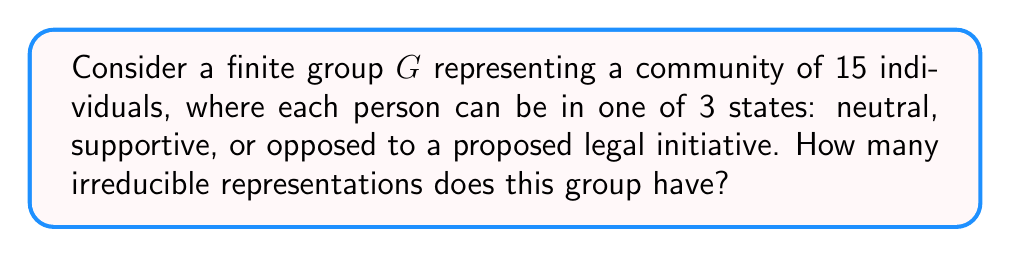Can you answer this question? To determine the number of irreducible representations for a finite group, we can follow these steps:

1. Identify the group: In this case, we have a finite group $G$ with $|G| = 15$.

2. Determine the number of conjugacy classes:
   For a group of order 15, the possible cycle structures are:
   - (1, 1, 1, 1, 1, 1, 1, 1, 1, 1, 1, 1, 1, 1, 1)
   - (3, 3, 3, 3, 3)
   - (5, 5, 5)
   
   There are 3 conjugacy classes corresponding to these cycle structures.

3. Apply the fundamental theorem of representation theory:
   The number of irreducible representations of a finite group is equal to the number of conjugacy classes in the group.

Therefore, the number of irreducible representations for this group is 3.

This result can be interpreted in the context of the outreach worker's role: The three irreducible representations could correspond to the three possible overall states of the community (neutral, supportive, or opposed) that the outreach worker needs to consider when liaising between the community and legal advisory bodies.
Answer: 3 